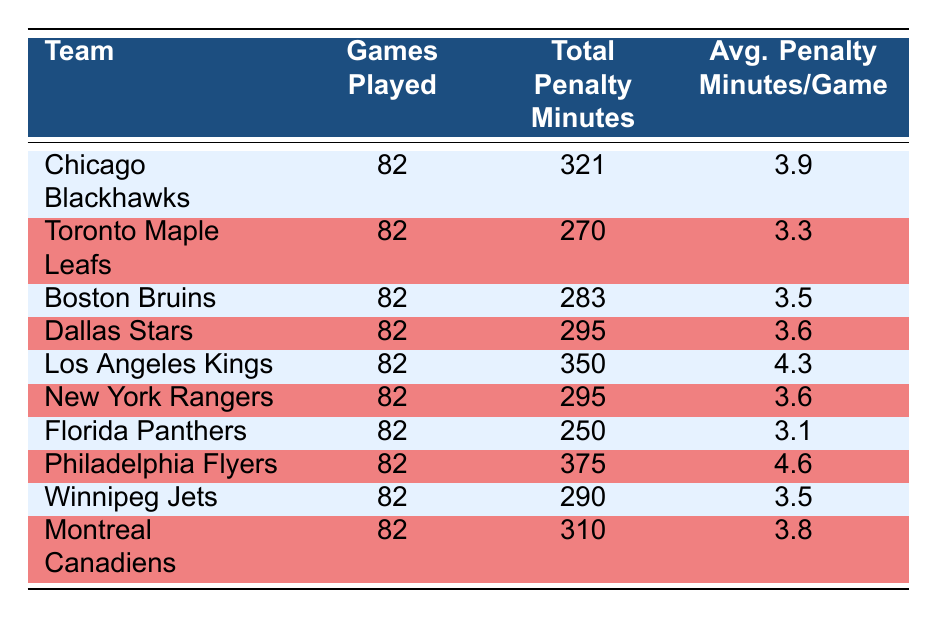What is the average penalty minutes per game for the Philadelphia Flyers? The table shows that the Philadelphia Flyers have 375 total penalty minutes over 82 games. The average penalty minutes per game is thus calculated as 375/82, which equals 4.6.
Answer: 4.6 Which team has the highest total penalty minutes? By scanning the 'Total Penalty Minutes' column in the table, we see that the Philadelphia Flyers have the highest total with 375 minutes.
Answer: Philadelphia Flyers What is the total penalty minutes for the Florida Panthers? The total penalty minutes for the Florida Panthers is directly listed in the table as 250.
Answer: 250 How many teams averaged more than 4 penalty minutes per game? We look at the 'Avg. Penalty Minutes/Game' column and identify that two teams, the Philadelphia Flyers (4.6) and the Los Angeles Kings (4.3), have averages exceeding 4 minutes.
Answer: 2 What is the difference in average penalty minutes per game between the Chicago Blackhawks and the Toronto Maple Leafs? The Chicago Blackhawks average 3.9 penalty minutes per game, and the Toronto Maple Leafs average 3.3. The difference is calculated as 3.9 - 3.3 = 0.6.
Answer: 0.6 True or False: The Boston Bruins accumulated fewer penalty minutes than the New York Rangers. The table shows the Boston Bruins with 283 total penalty minutes and the New York Rangers with 295. Since 283 is less than 295, the statement is true.
Answer: True What are the average penalty minutes per game for the team with the lowest total penalty minutes? The Florida Panthers have the lowest total penalty minutes (250) amongst all teams, averaging 3.1 penalty minutes per game.
Answer: 3.1 Calculate the total penalty minutes for teams averaging less than 3.5 minutes per game. The teams with averages below 3.5 are the Toronto Maple Leafs (270), Florida Panthers (250), and the Winnipeg Jets (290). Summing these values gives us 270 + 250 + 290 = 810 total penalty minutes.
Answer: 810 If you combined the average penalty minutes for the Blackhawks, Kings, and Flyers, what would that total? The average penalty minutes for the Blackhawks is 3.9, for the Kings is 4.3, and for the Flyers is 4.6. Adding these gives us 3.9 + 4.3 + 4.6 = 12.8.
Answer: 12.8 